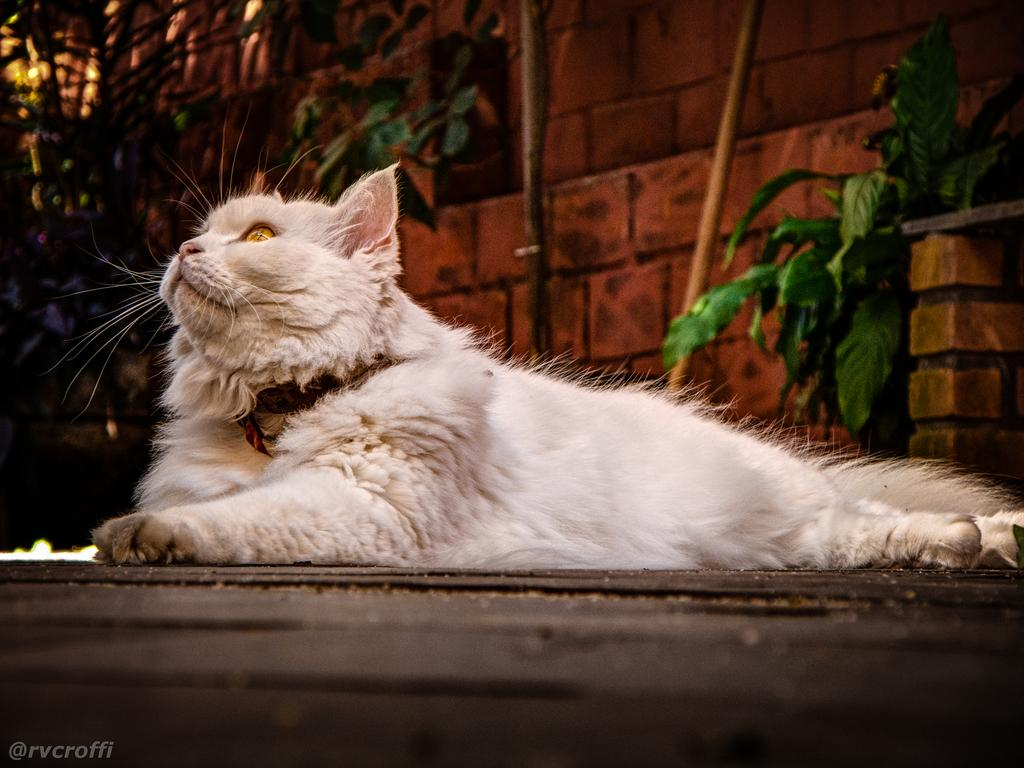What type of animal is in the image? There is a white color cat in the image. What is the cat doing in the image? The cat is laying on the ground and looking upwards. What can be seen in the background of the image? There is a red color wall and plants in the background of the image. What type of egg treatment is the cat receiving in the image? There is no egg treatment present in the image; it features a white color cat laying on the ground and looking upwards. How many rings can be seen on the cat's tail in the image? There are no rings visible on the cat's tail in the image. 